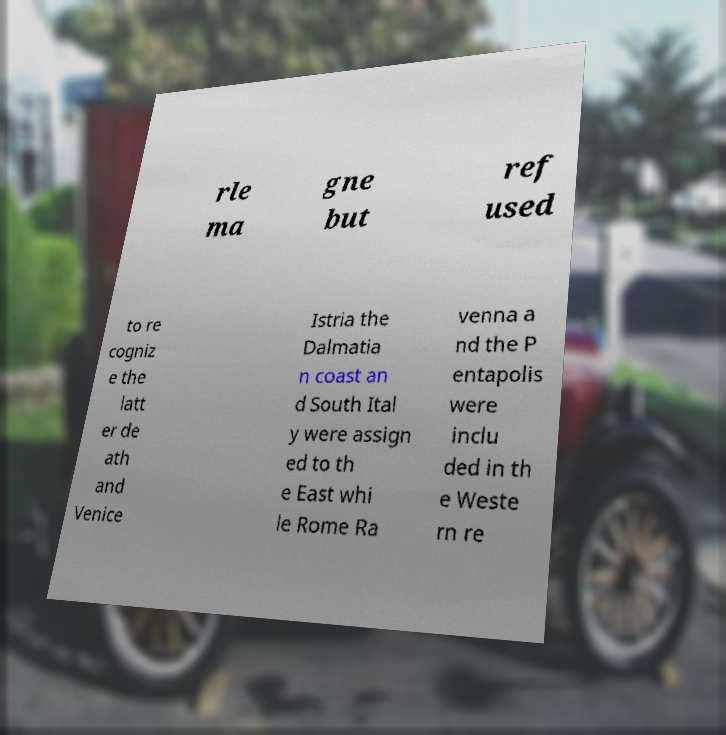I need the written content from this picture converted into text. Can you do that? rle ma gne but ref used to re cogniz e the latt er de ath and Venice Istria the Dalmatia n coast an d South Ital y were assign ed to th e East whi le Rome Ra venna a nd the P entapolis were inclu ded in th e Weste rn re 